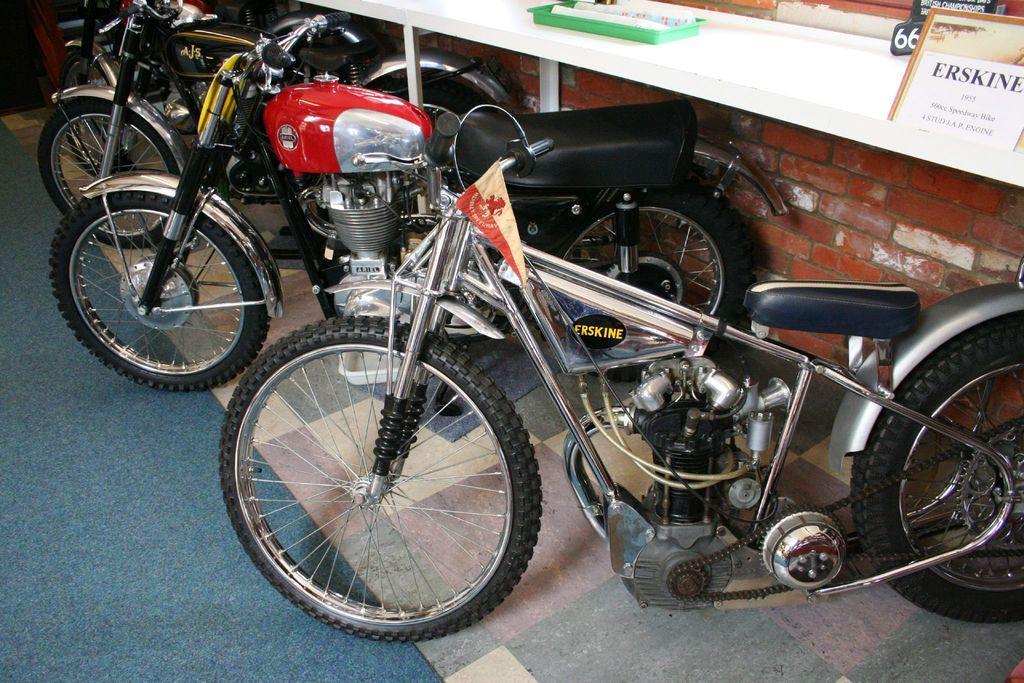How would you summarize this image in a sentence or two? In this picture I can see few motorcycles parked and I can see a paper on the board and a tray on the table and carpet on the floor. 